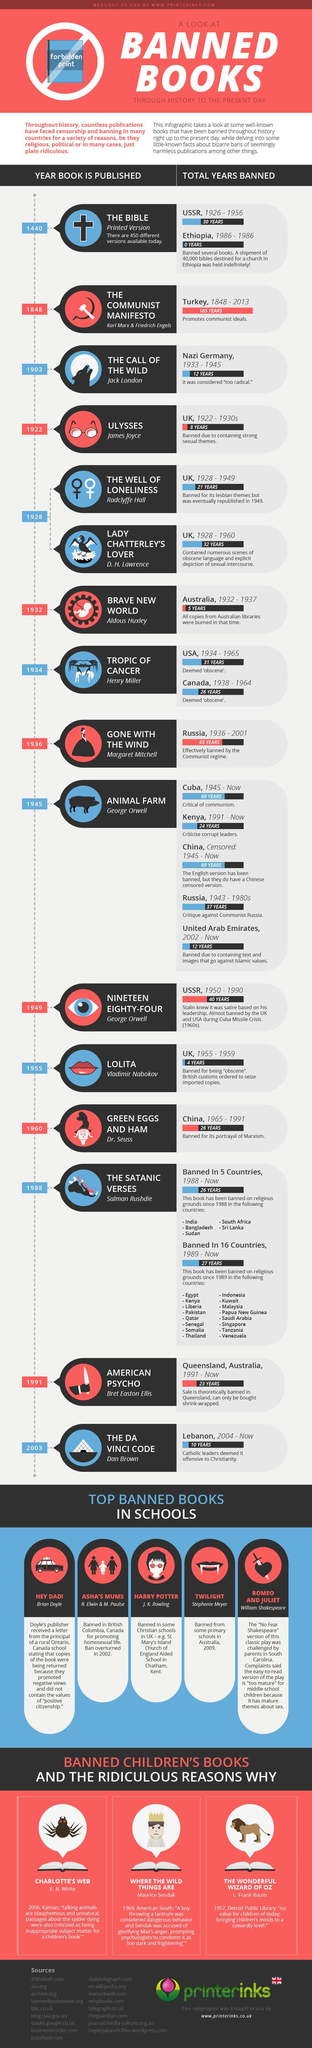which book is given in the middle column in banned children's books?
Answer the question with a short phrase. Where the wild things are How many banned books in this infographic were published in 20th century? 13 Which of the books given in this infographic were banned by Australia? Brave new world, American psycho Which of the books given in this infographic were banned by the USSR? The Bible, Nineteen eighty-four In which year did India ban "The satanic verses"? 1988 How many books in this infographic were banned by UK? 4 Which of the books given in this infographic were banned by Australia? tropic of cancer Which of the books given in this infographic were banned by UK in 1920s? Ulysses, the well of loneliness, lady Chatterley's love who are the authors of banned children's books given in this infographic? E. B. White, Maurice Sendak, L. Frank Baum In how many countries are "The satanic verses" banned? 21 Which countries have banned the Bible? USSR, Ethiopia Which of the books given in this infographic were banned by China? Animal farm, Green eggs and Ham 